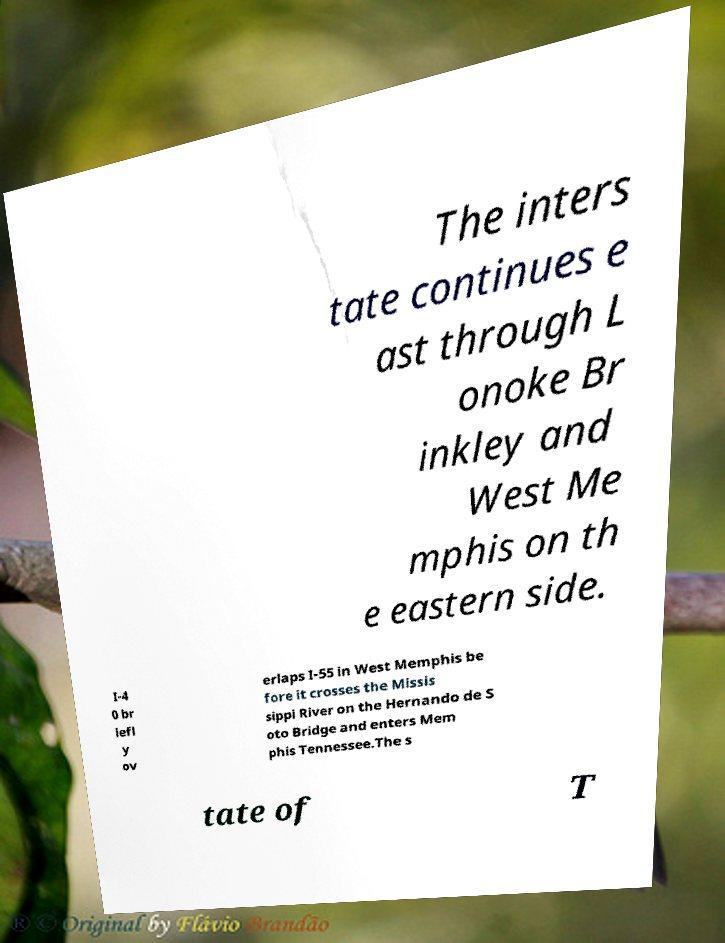Could you extract and type out the text from this image? The inters tate continues e ast through L onoke Br inkley and West Me mphis on th e eastern side. I-4 0 br iefl y ov erlaps I-55 in West Memphis be fore it crosses the Missis sippi River on the Hernando de S oto Bridge and enters Mem phis Tennessee.The s tate of T 